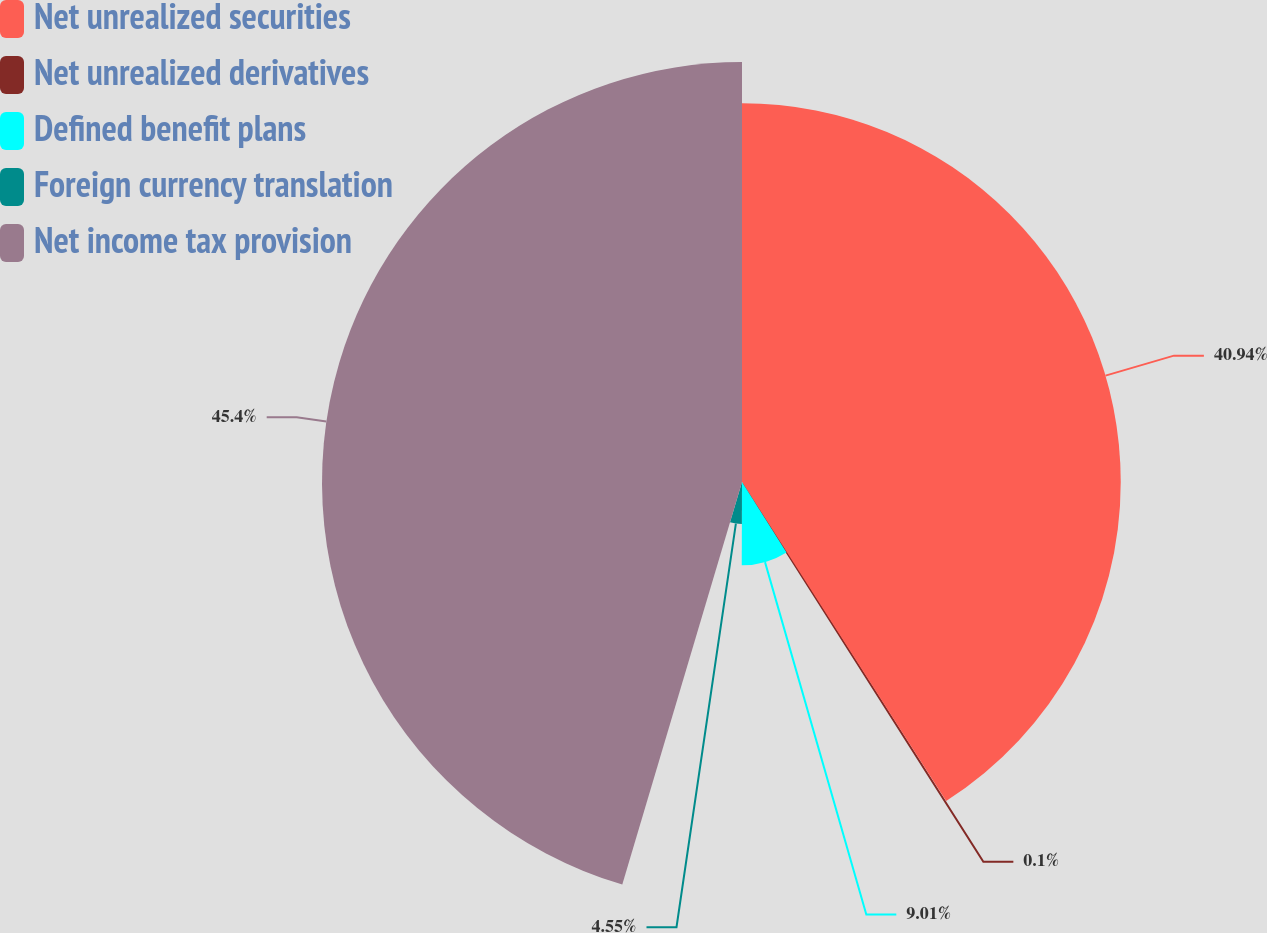<chart> <loc_0><loc_0><loc_500><loc_500><pie_chart><fcel>Net unrealized securities<fcel>Net unrealized derivatives<fcel>Defined benefit plans<fcel>Foreign currency translation<fcel>Net income tax provision<nl><fcel>40.94%<fcel>0.1%<fcel>9.01%<fcel>4.55%<fcel>45.4%<nl></chart> 